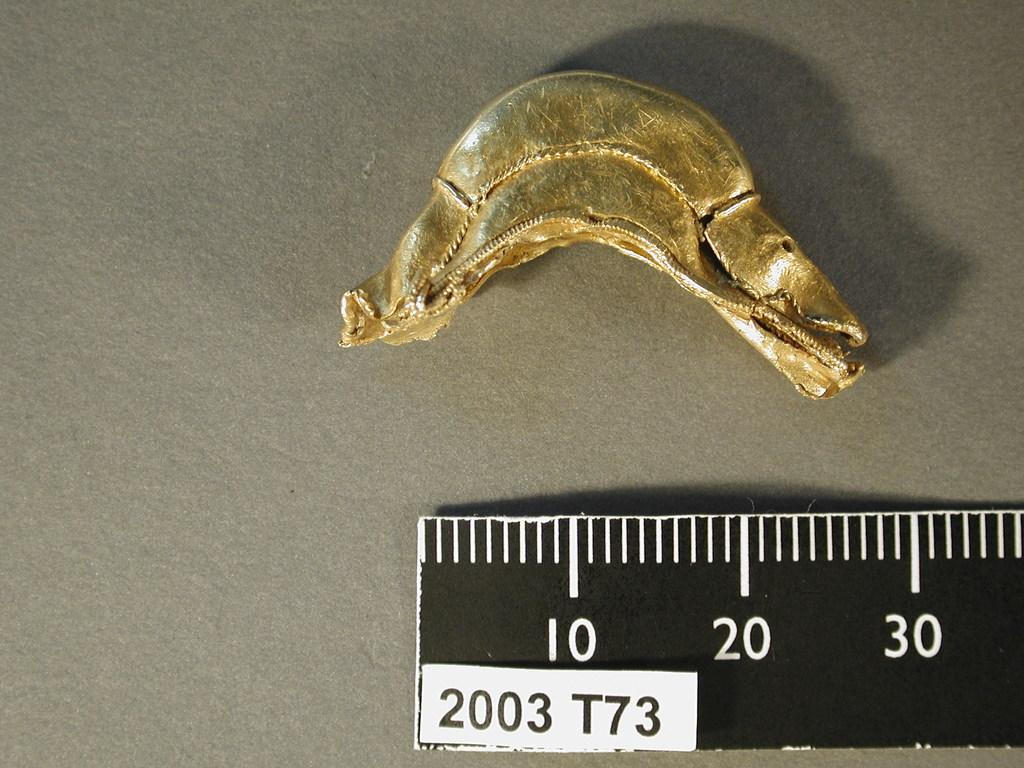<image>
Write a terse but informative summary of the picture. A curved, gold object being measured by a black ruler, showing a lenghe of approximately 30. 